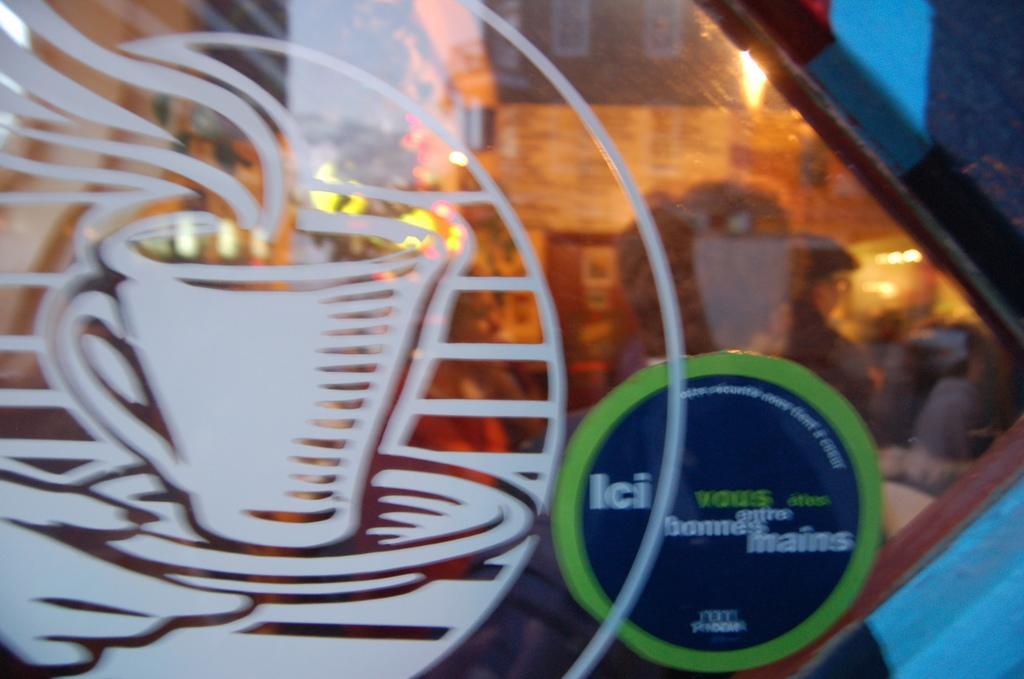Please provide a concise description of this image. In this picture I can observe a glass. There is a painting of a cup on the glass. This painting is in white color. In the background there are some people. I can observe yellow color light. 